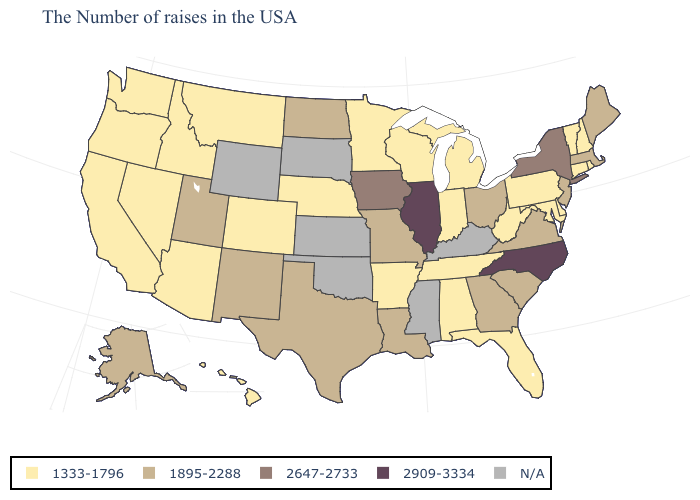What is the highest value in states that border South Dakota?
Give a very brief answer. 2647-2733. How many symbols are there in the legend?
Give a very brief answer. 5. Is the legend a continuous bar?
Write a very short answer. No. What is the lowest value in the MidWest?
Be succinct. 1333-1796. What is the value of Hawaii?
Write a very short answer. 1333-1796. Name the states that have a value in the range N/A?
Short answer required. Kentucky, Mississippi, Kansas, Oklahoma, South Dakota, Wyoming. Name the states that have a value in the range N/A?
Quick response, please. Kentucky, Mississippi, Kansas, Oklahoma, South Dakota, Wyoming. What is the highest value in the MidWest ?
Be succinct. 2909-3334. Name the states that have a value in the range N/A?
Be succinct. Kentucky, Mississippi, Kansas, Oklahoma, South Dakota, Wyoming. What is the value of Alaska?
Give a very brief answer. 1895-2288. What is the highest value in the South ?
Write a very short answer. 2909-3334. What is the value of Louisiana?
Give a very brief answer. 1895-2288. Name the states that have a value in the range 1895-2288?
Short answer required. Maine, Massachusetts, New Jersey, Virginia, South Carolina, Ohio, Georgia, Louisiana, Missouri, Texas, North Dakota, New Mexico, Utah, Alaska. 